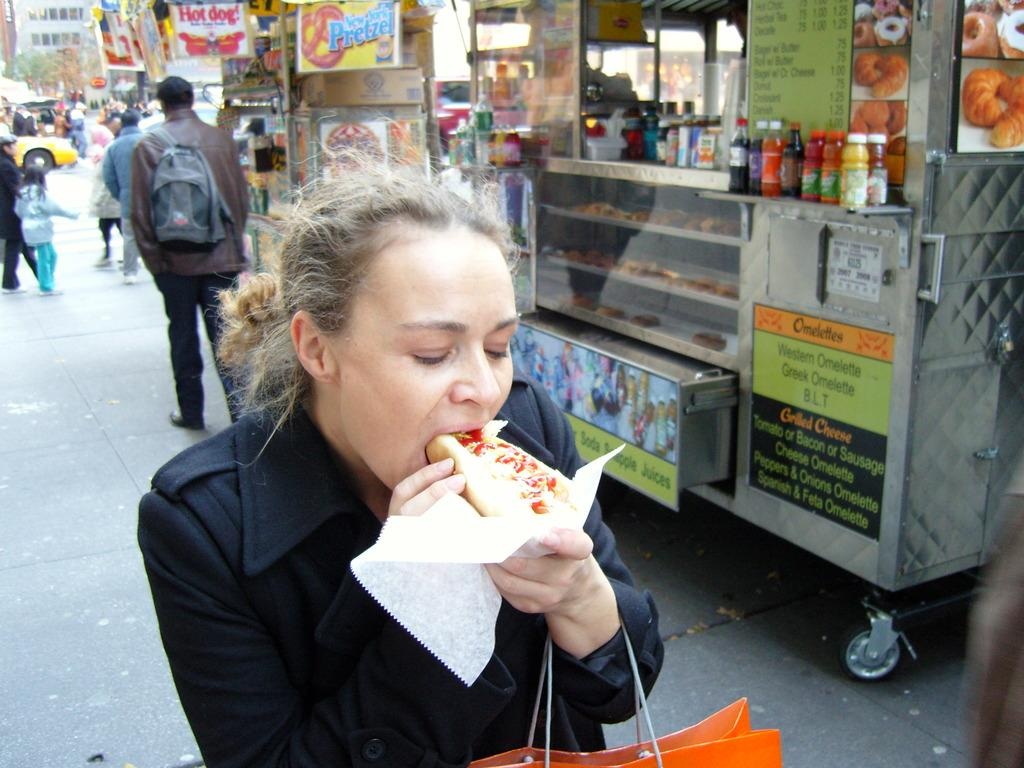<image>
Present a compact description of the photo's key features. A food truck has a sign advertising Greek and western omelettes. 